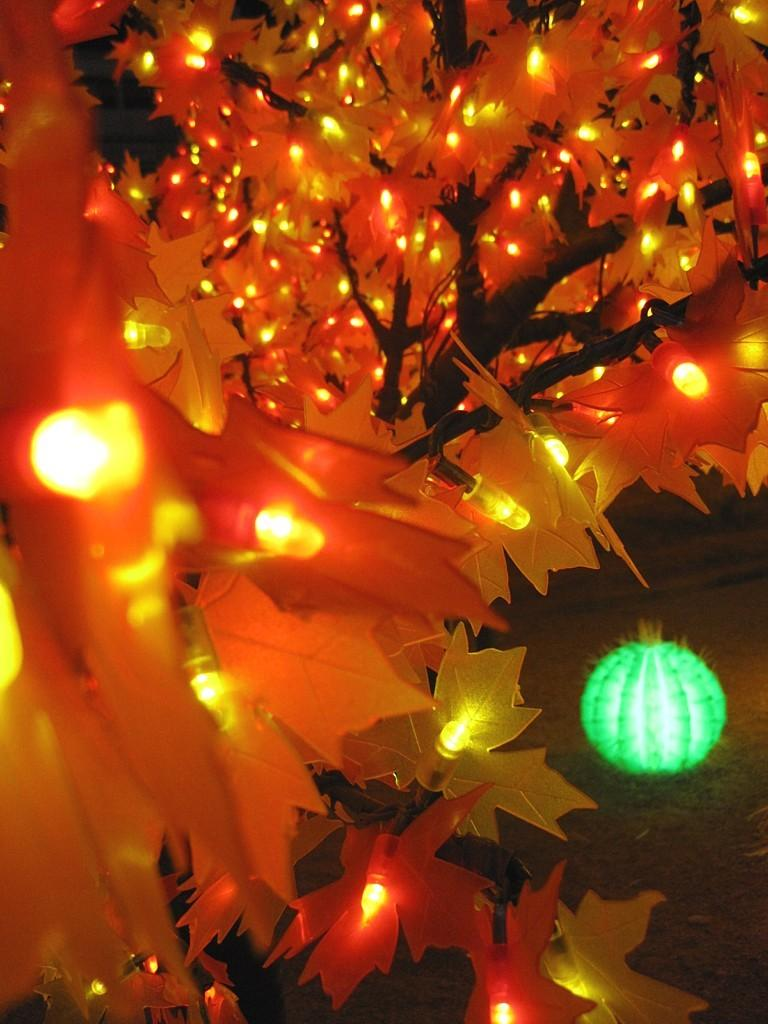What is located in the foreground of the image? There is a tree in the foreground of the image. What is attached to the tree? Lights are attached to the tree. What can be seen in the background of the image? There is a green colored light balloon in the background of the image. What type of border is visible around the tree in the image? There is no border visible around the tree in the image. How does the tree look in the image? The tree looks like a tree with lights attached to it, as described in the facts. 